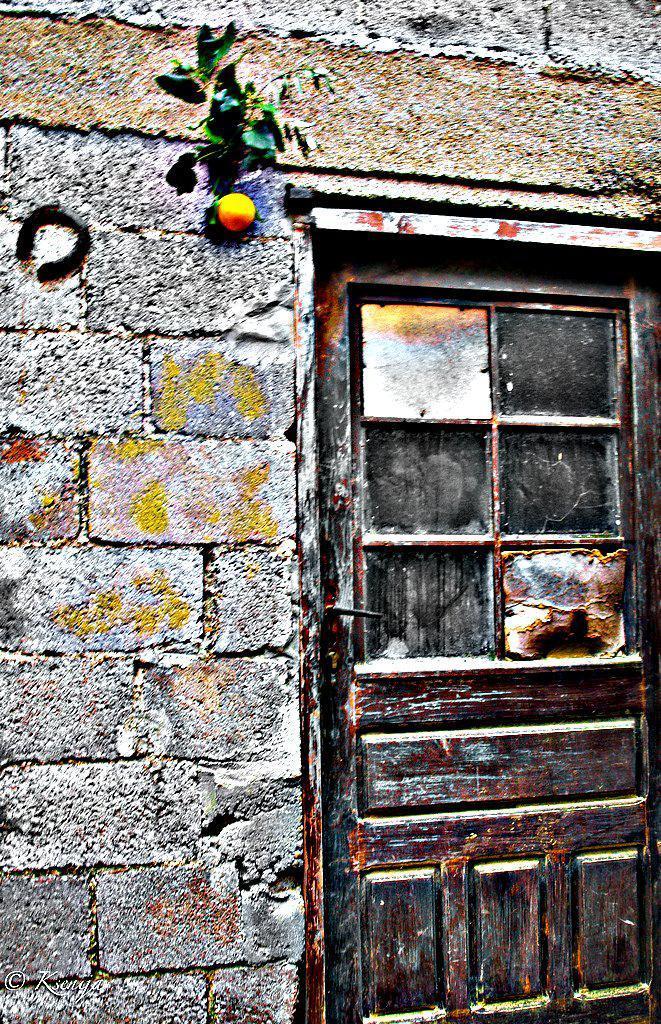Could you give a brief overview of what you see in this image? On the right of this picture we can see a wooden door. In the center we can see the leaves and an object and we can see the stone wall. 